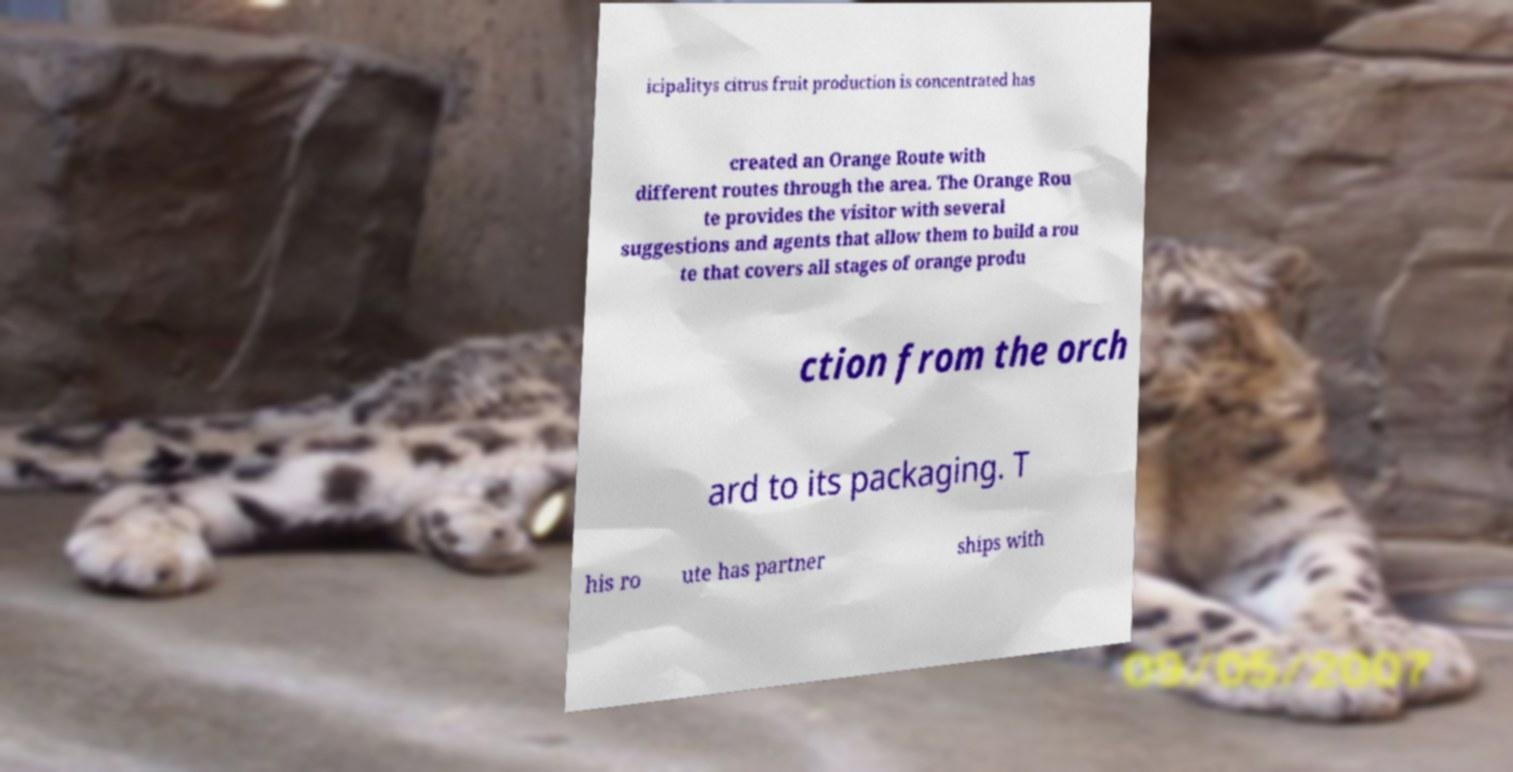There's text embedded in this image that I need extracted. Can you transcribe it verbatim? icipalitys citrus fruit production is concentrated has created an Orange Route with different routes through the area. The Orange Rou te provides the visitor with several suggestions and agents that allow them to build a rou te that covers all stages of orange produ ction from the orch ard to its packaging. T his ro ute has partner ships with 